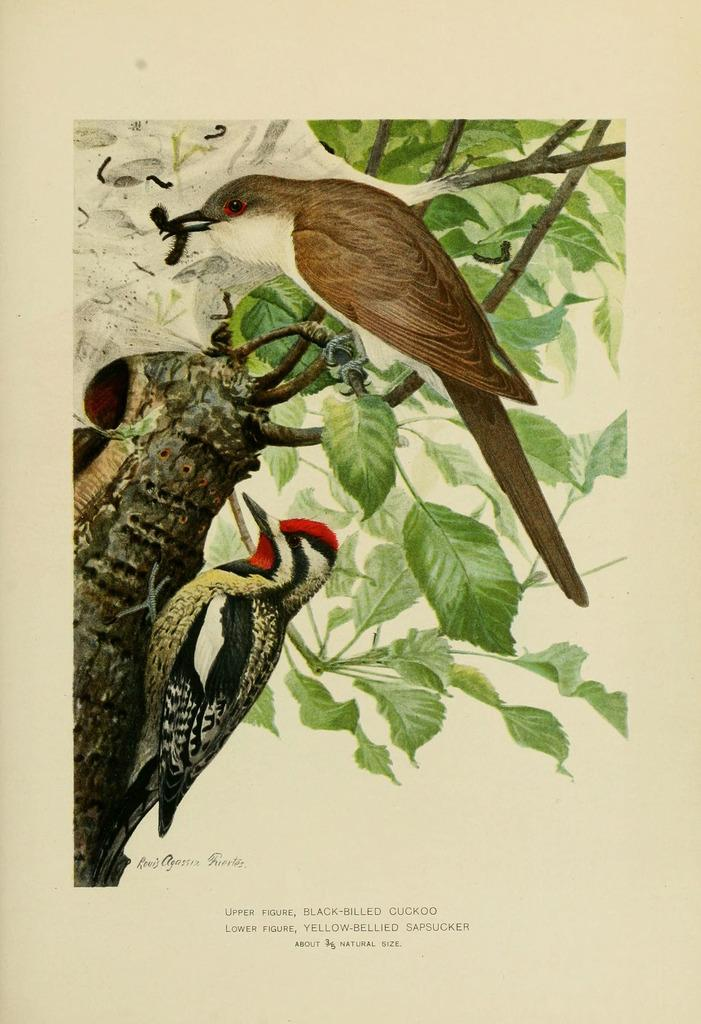What type of artwork is depicted in the image? The image is a painting. What animals can be seen in the painting? There are birds in the painting. Where are the birds located in the painting? The birds are on a tree. What time of day is represented by the hour in the painting? There is no hour present in the painting; it is a painting of birds on a tree. 